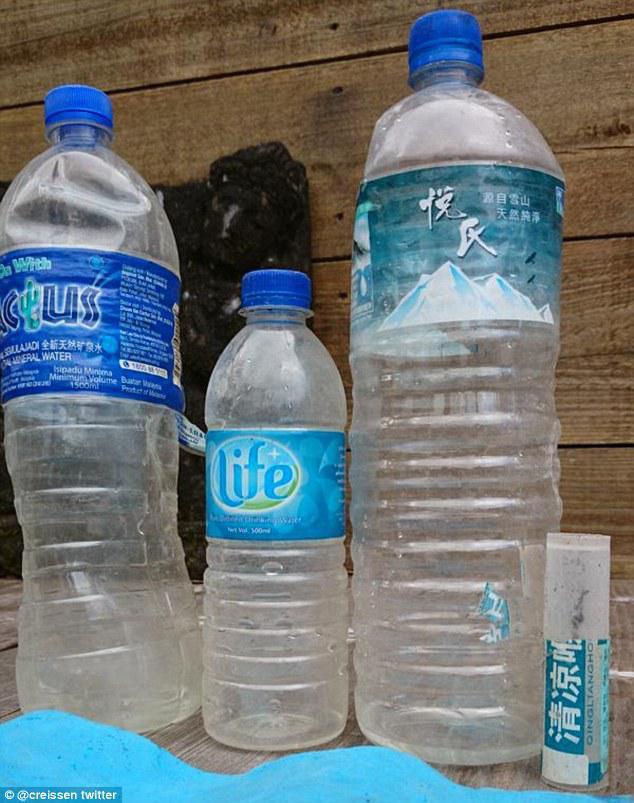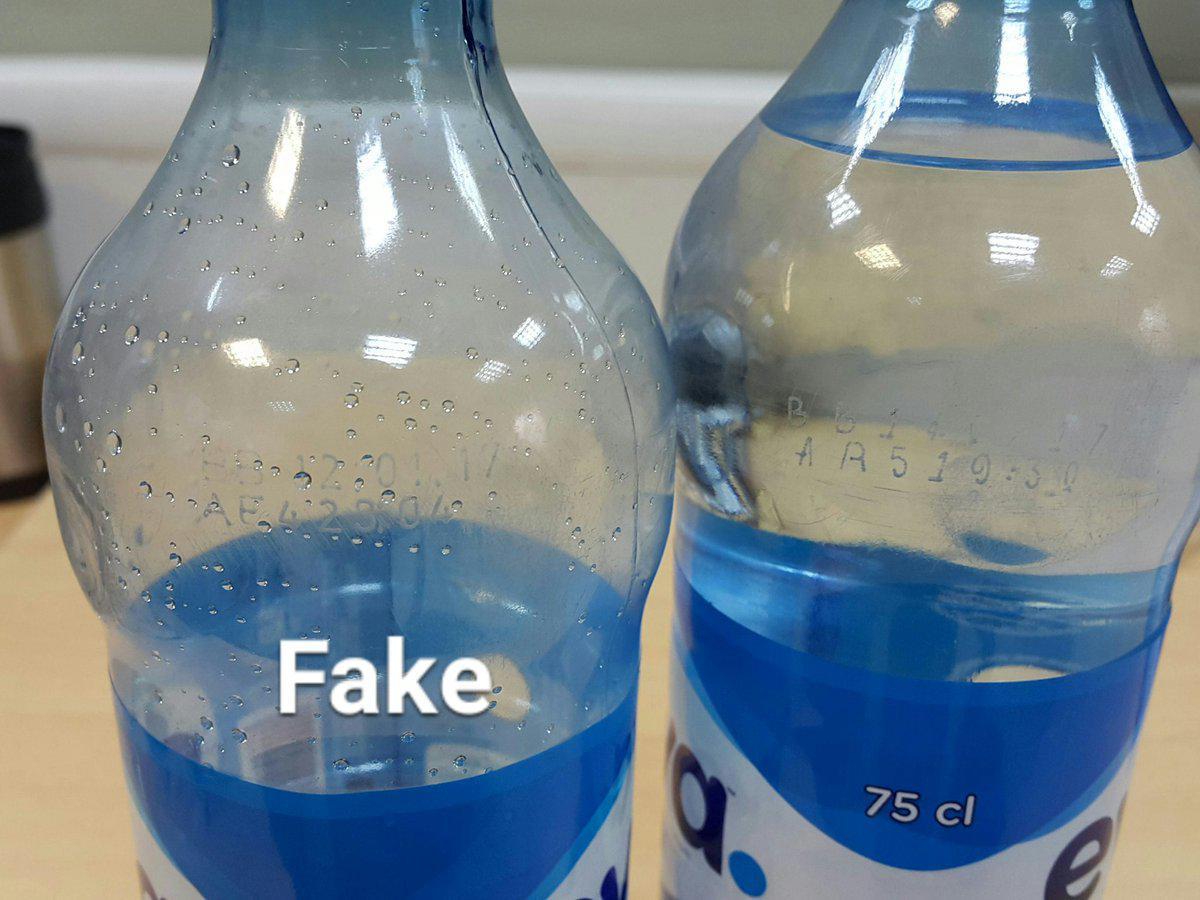The first image is the image on the left, the second image is the image on the right. For the images displayed, is the sentence "At least four bottles in the image on the left side have blue lids." factually correct? Answer yes or no. No. 